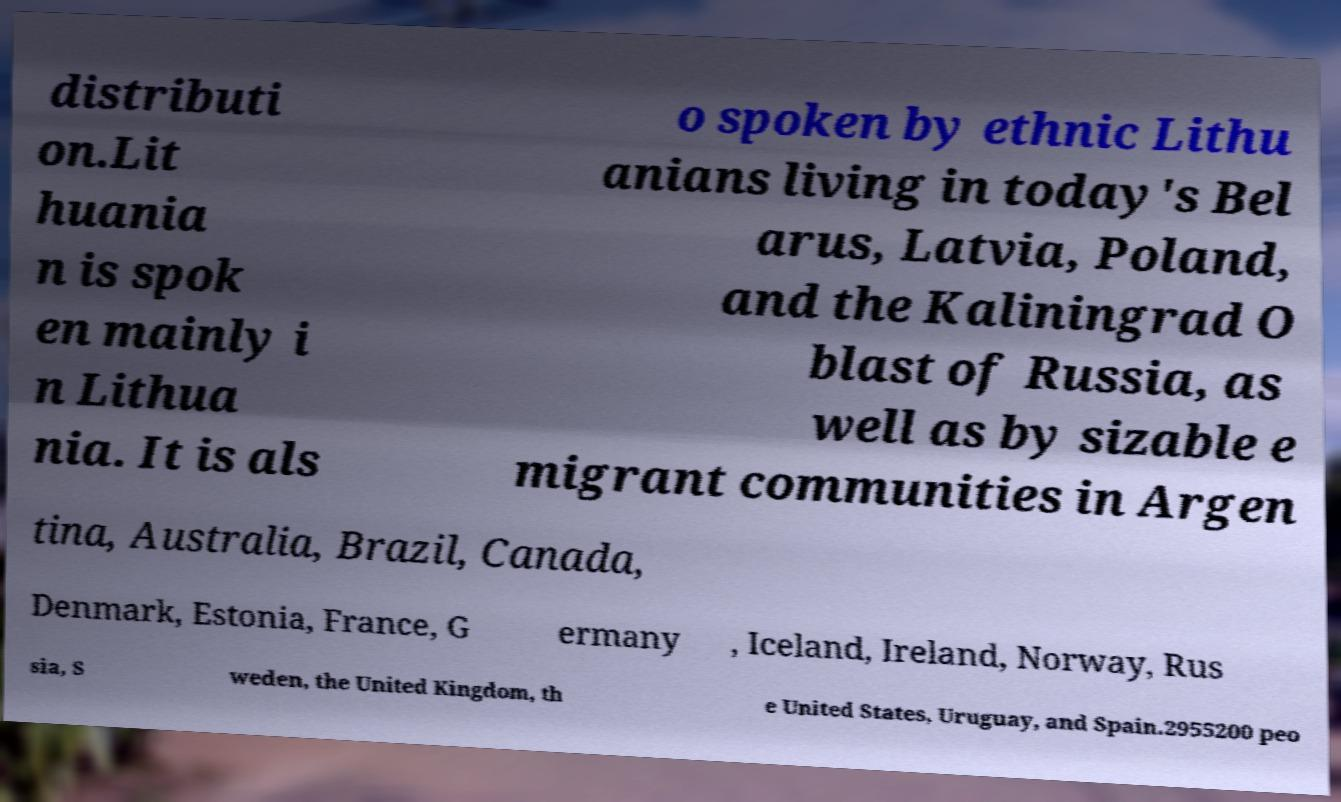I need the written content from this picture converted into text. Can you do that? distributi on.Lit huania n is spok en mainly i n Lithua nia. It is als o spoken by ethnic Lithu anians living in today's Bel arus, Latvia, Poland, and the Kaliningrad O blast of Russia, as well as by sizable e migrant communities in Argen tina, Australia, Brazil, Canada, Denmark, Estonia, France, G ermany , Iceland, Ireland, Norway, Rus sia, S weden, the United Kingdom, th e United States, Uruguay, and Spain.2955200 peo 